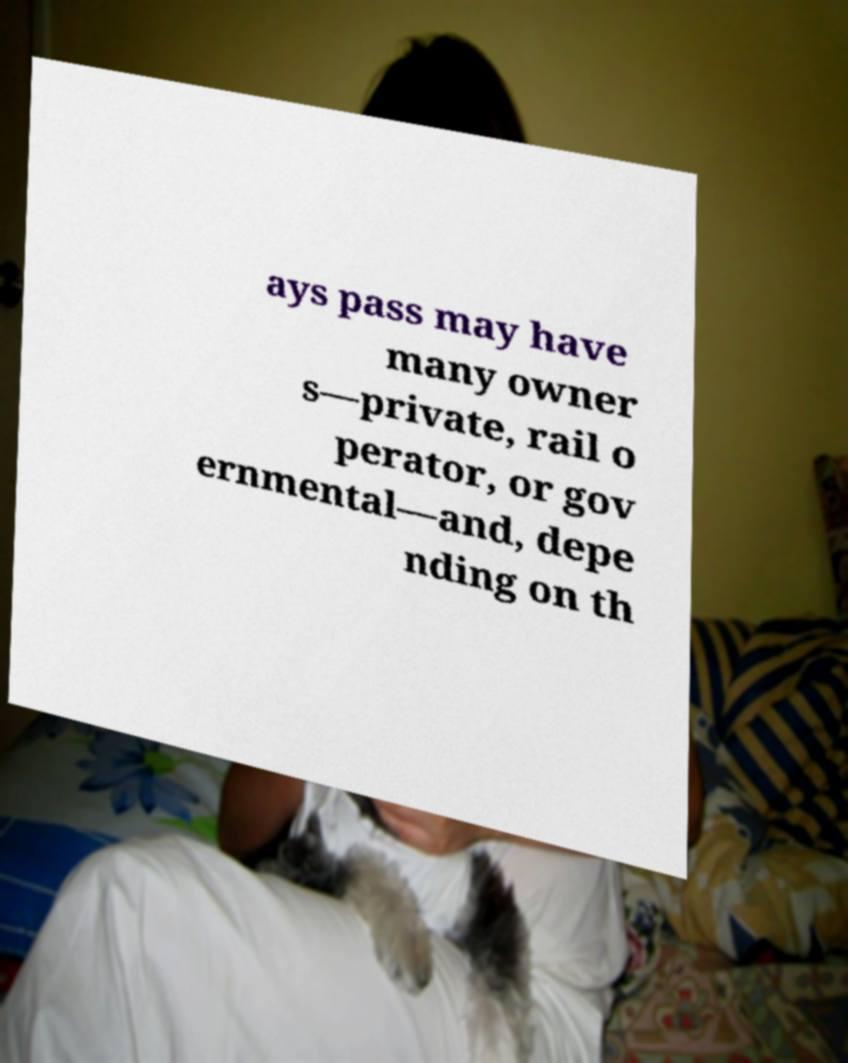There's text embedded in this image that I need extracted. Can you transcribe it verbatim? ays pass may have many owner s—private, rail o perator, or gov ernmental—and, depe nding on th 